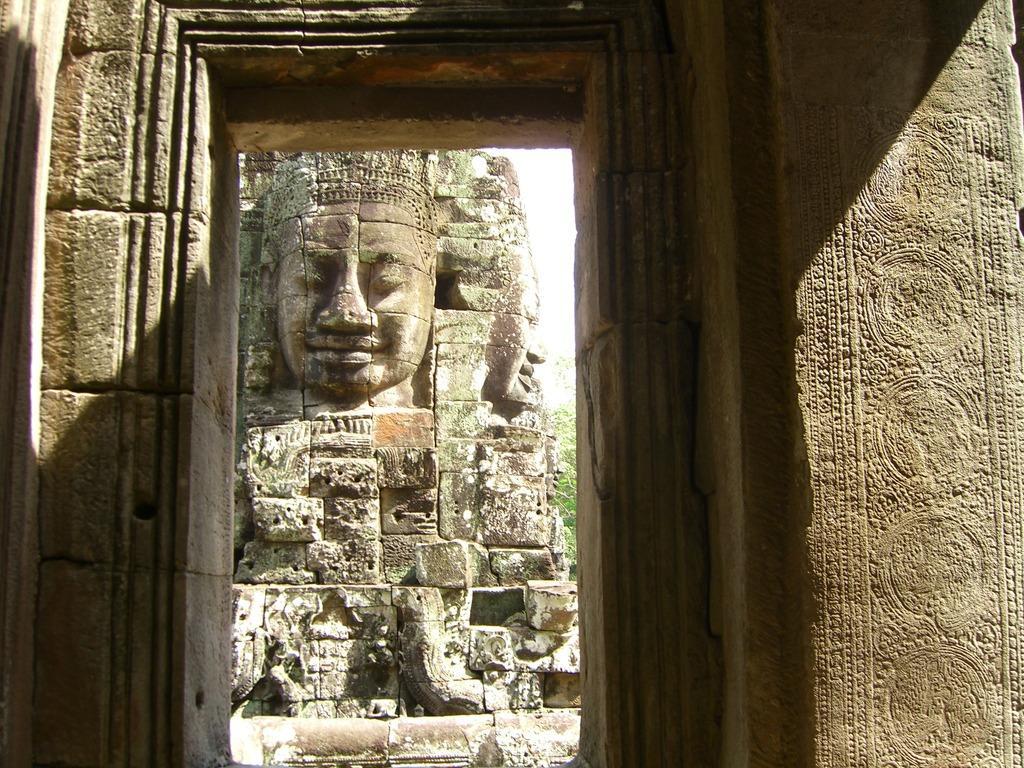In one or two sentences, can you explain what this image depicts? In this image there is a door to the wall having few sculptures on it. Behind the door there is a statue having two person faces. Beside the statue there is tree. Top of it there is sky. 